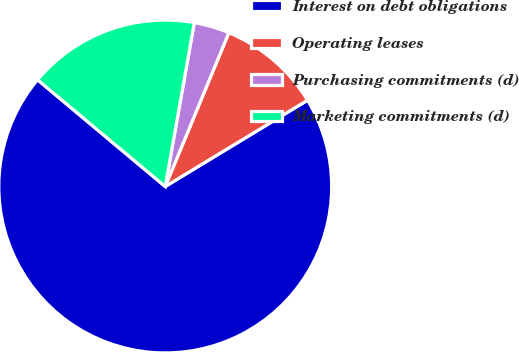Convert chart. <chart><loc_0><loc_0><loc_500><loc_500><pie_chart><fcel>Interest on debt obligations<fcel>Operating leases<fcel>Purchasing commitments (d)<fcel>Marketing commitments (d)<nl><fcel>69.75%<fcel>10.08%<fcel>3.45%<fcel>16.71%<nl></chart> 